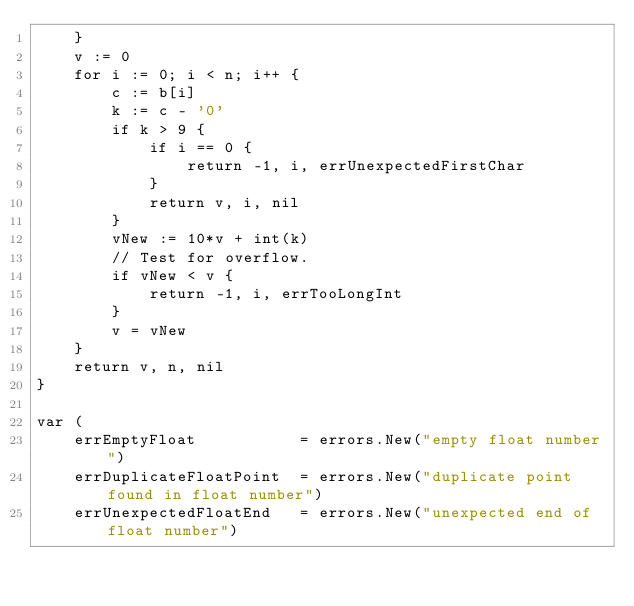<code> <loc_0><loc_0><loc_500><loc_500><_Go_>	}
	v := 0
	for i := 0; i < n; i++ {
		c := b[i]
		k := c - '0'
		if k > 9 {
			if i == 0 {
				return -1, i, errUnexpectedFirstChar
			}
			return v, i, nil
		}
		vNew := 10*v + int(k)
		// Test for overflow.
		if vNew < v {
			return -1, i, errTooLongInt
		}
		v = vNew
	}
	return v, n, nil
}

var (
	errEmptyFloat           = errors.New("empty float number")
	errDuplicateFloatPoint  = errors.New("duplicate point found in float number")
	errUnexpectedFloatEnd   = errors.New("unexpected end of float number")</code> 